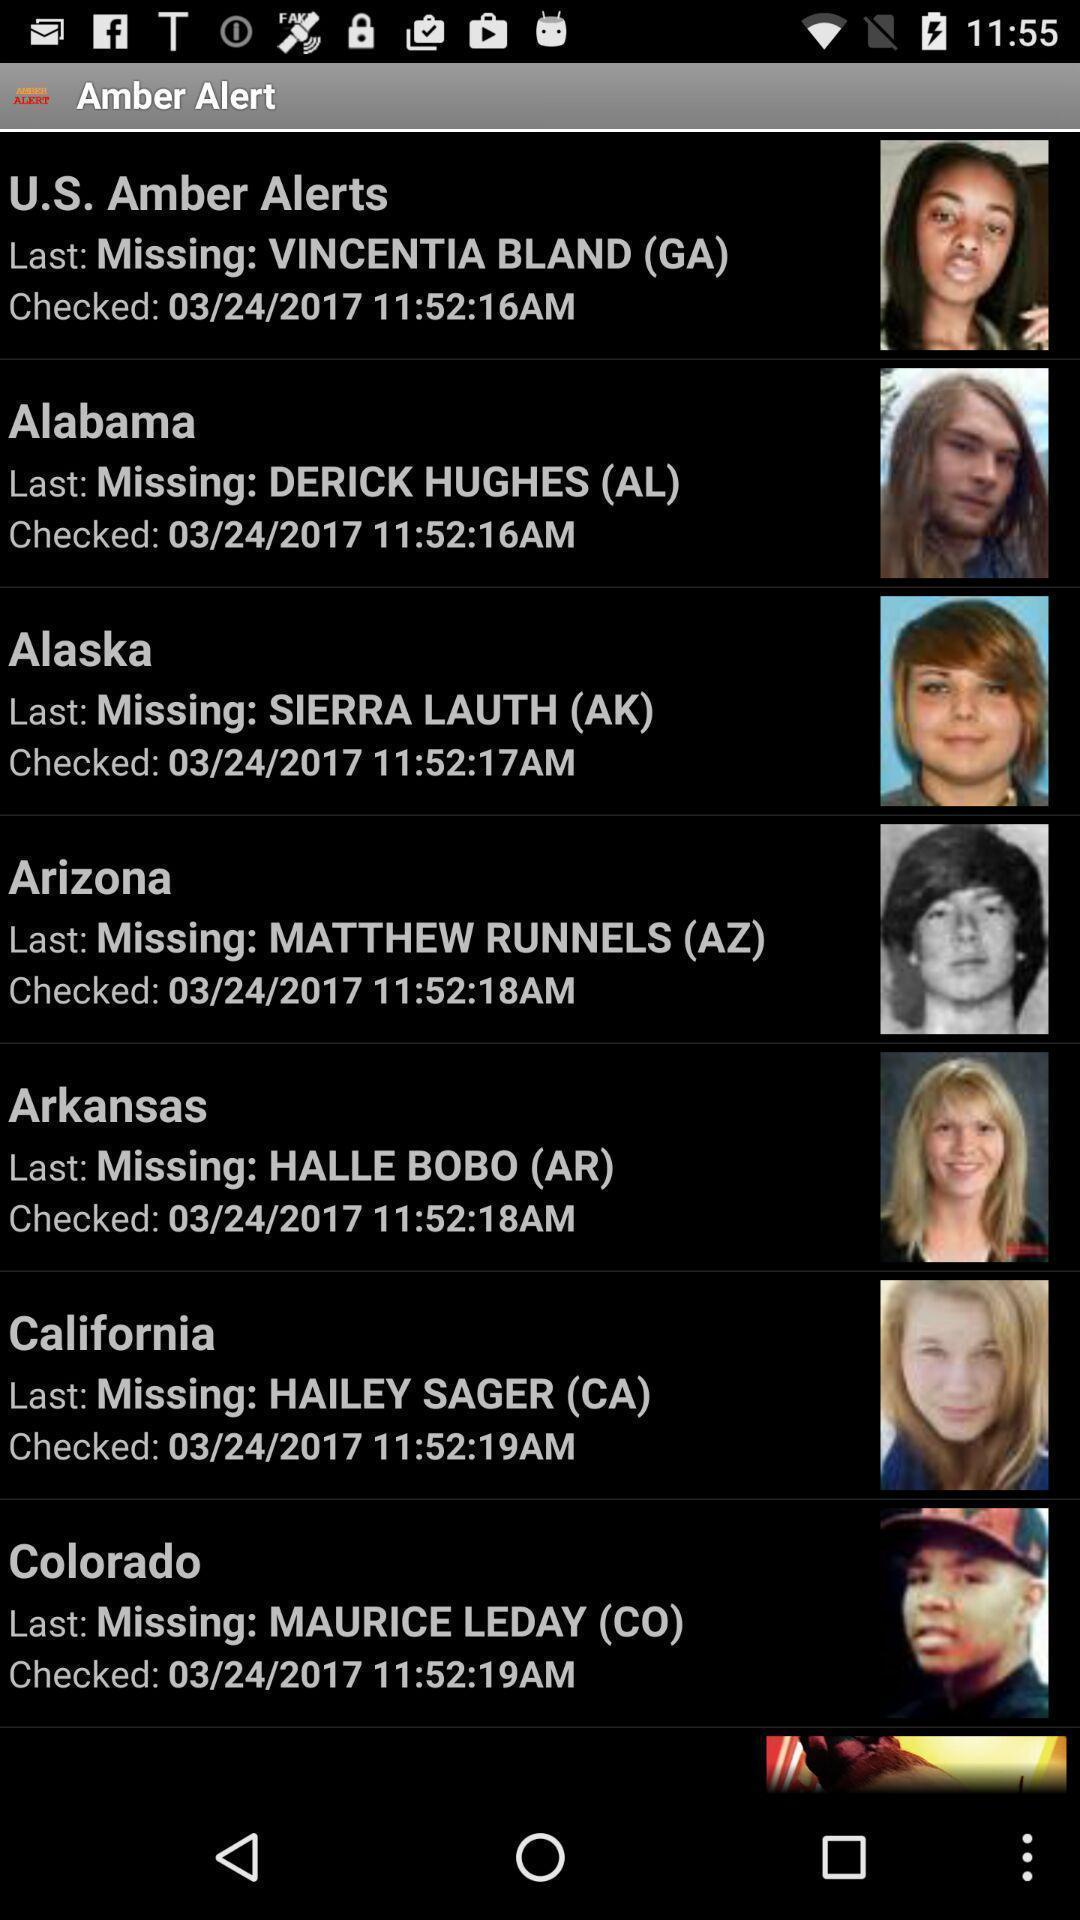What can you discern from this picture? Screen displaying alert 's. 